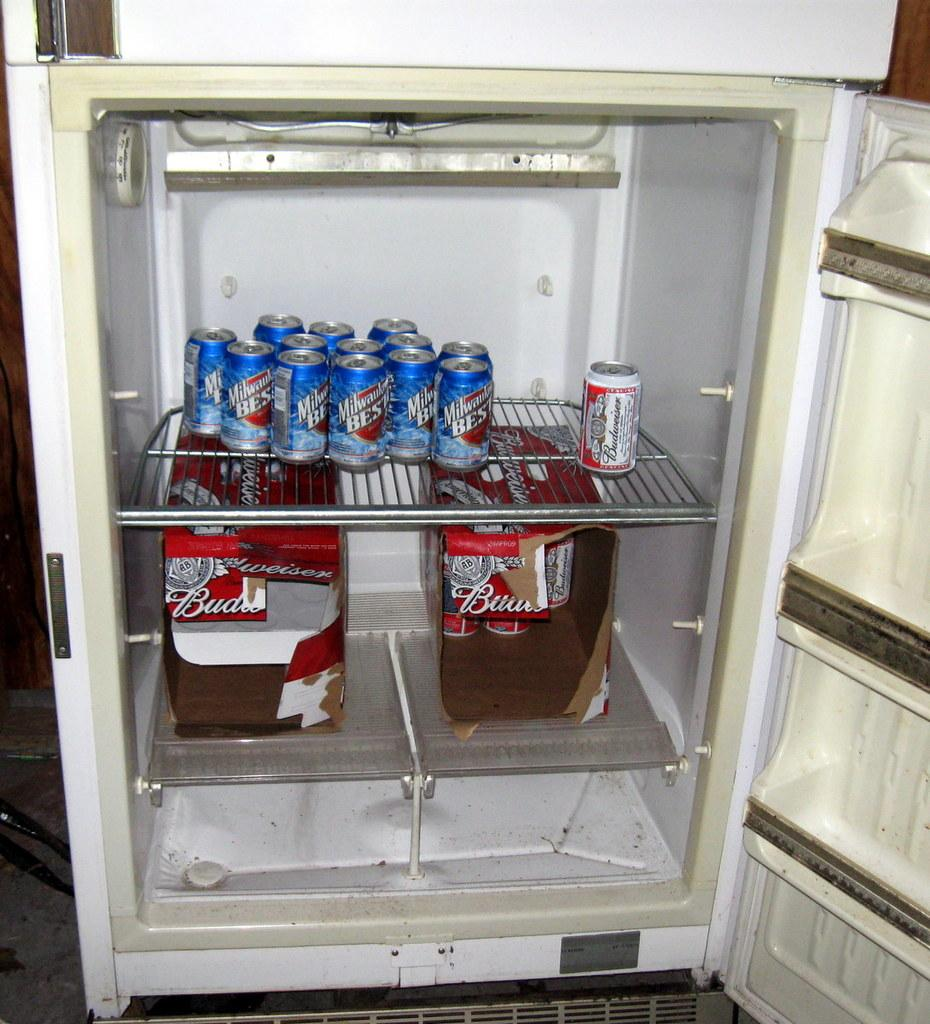<image>
Offer a succinct explanation of the picture presented. An open refrigerator reveals both Budweiser and Milwaukee's Best inside. 